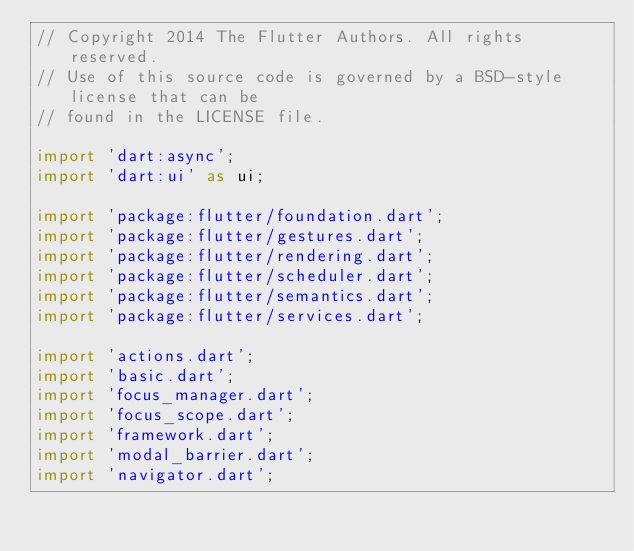<code> <loc_0><loc_0><loc_500><loc_500><_Dart_>// Copyright 2014 The Flutter Authors. All rights reserved.
// Use of this source code is governed by a BSD-style license that can be
// found in the LICENSE file.

import 'dart:async';
import 'dart:ui' as ui;

import 'package:flutter/foundation.dart';
import 'package:flutter/gestures.dart';
import 'package:flutter/rendering.dart';
import 'package:flutter/scheduler.dart';
import 'package:flutter/semantics.dart';
import 'package:flutter/services.dart';

import 'actions.dart';
import 'basic.dart';
import 'focus_manager.dart';
import 'focus_scope.dart';
import 'framework.dart';
import 'modal_barrier.dart';
import 'navigator.dart';</code> 